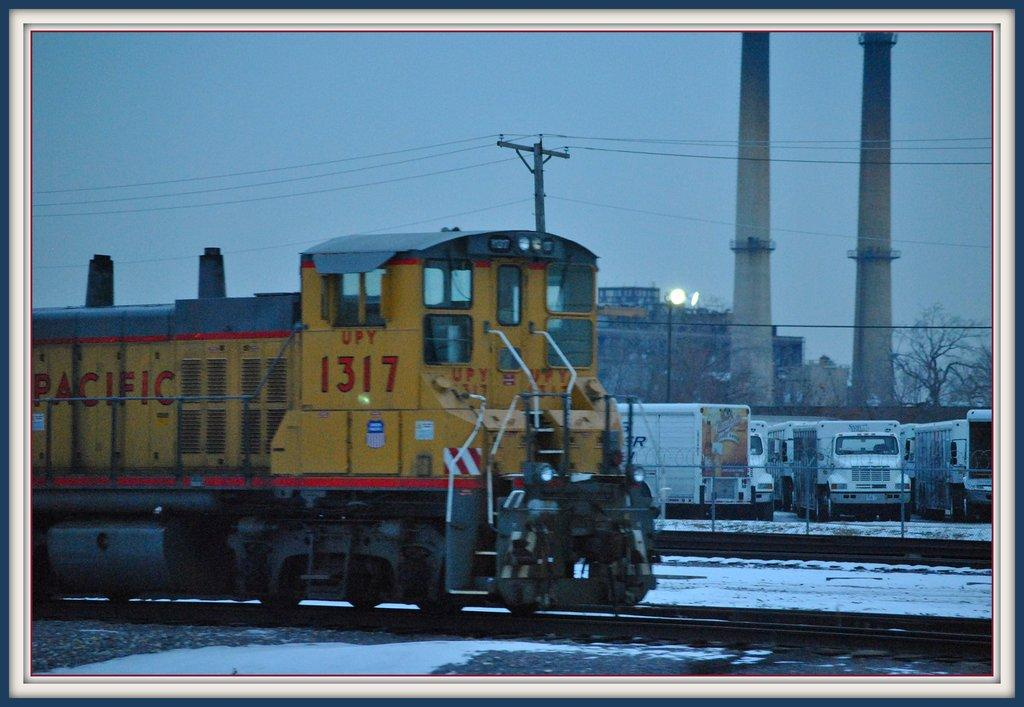What is the main subject of the image? The main subject of the image is a train. What can be seen in the image besides the train? There is a railway track, a light pole, vehicles, a building, a tree, an electric pole, wires, snow, and the sky visible in the image. Can you describe the environment in the image? The image shows a snowy environment with a train on a railway track, surrounded by various structures and objects. What type of scent can be detected in the image? There is no mention of any scent in the image, so it cannot be determined from the image. --- Facts: 1. There is a person holding a camera in the image. 2. The person is standing on a bridge. 3. There is a river below the bridge. 4. There are boats on the river. 5. The sky is visible in the image. Absurd Topics: dinosaur, volcano, parachute Conversation: What is the person in the image doing? The person in the image is holding a camera. Where is the person standing in the image? The person is standing on a bridge. What can be seen below the bridge in the image? There is a river below the bridge, and boats are on the river. What is visible in the sky in the image? The sky is visible in the image. Reasoning: Let's think step by step in order to produce the conversation. We start by identifying the main subject of the image, which is the person holding a camera. Then, we expand the conversation to include the person's location (on a bridge) and the surrounding environment (river, boats, and sky). Each question is designed to elicit a specific detail about the image that is known from the provided facts. Absurd Question/Answer: Is there a dinosaur visible in the image? No, there is no dinosaur present in the image. 